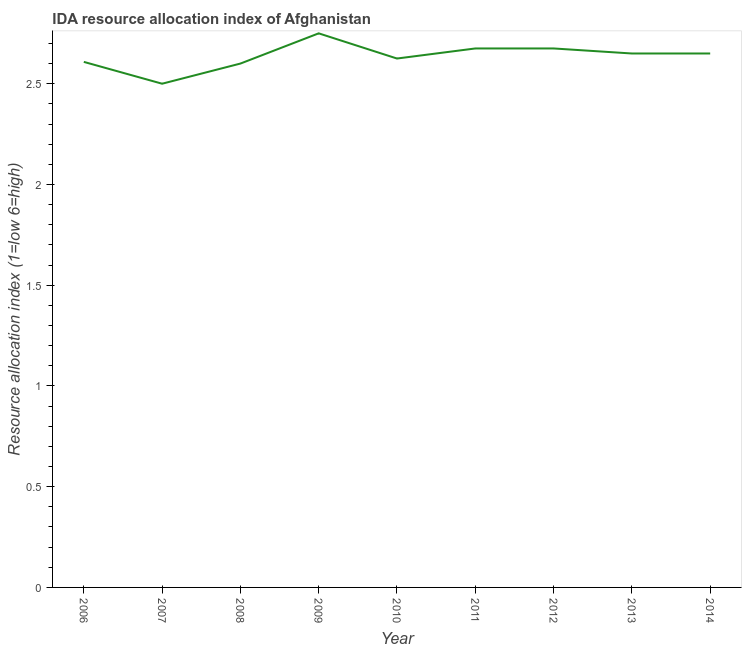Across all years, what is the maximum ida resource allocation index?
Provide a short and direct response. 2.75. Across all years, what is the minimum ida resource allocation index?
Provide a short and direct response. 2.5. In which year was the ida resource allocation index maximum?
Offer a very short reply. 2009. In which year was the ida resource allocation index minimum?
Make the answer very short. 2007. What is the sum of the ida resource allocation index?
Provide a succinct answer. 23.73. What is the difference between the ida resource allocation index in 2007 and 2009?
Offer a terse response. -0.25. What is the average ida resource allocation index per year?
Offer a very short reply. 2.64. What is the median ida resource allocation index?
Provide a short and direct response. 2.65. In how many years, is the ida resource allocation index greater than 2.4 ?
Provide a succinct answer. 9. What is the ratio of the ida resource allocation index in 2010 to that in 2014?
Offer a terse response. 0.99. Is the difference between the ida resource allocation index in 2006 and 2010 greater than the difference between any two years?
Provide a succinct answer. No. What is the difference between the highest and the second highest ida resource allocation index?
Your response must be concise. 0.08. Is the sum of the ida resource allocation index in 2008 and 2011 greater than the maximum ida resource allocation index across all years?
Make the answer very short. Yes. In how many years, is the ida resource allocation index greater than the average ida resource allocation index taken over all years?
Provide a succinct answer. 5. Does the ida resource allocation index monotonically increase over the years?
Provide a succinct answer. No. How many lines are there?
Your response must be concise. 1. What is the difference between two consecutive major ticks on the Y-axis?
Your answer should be very brief. 0.5. Are the values on the major ticks of Y-axis written in scientific E-notation?
Provide a short and direct response. No. Does the graph contain any zero values?
Your answer should be very brief. No. What is the title of the graph?
Make the answer very short. IDA resource allocation index of Afghanistan. What is the label or title of the Y-axis?
Provide a short and direct response. Resource allocation index (1=low 6=high). What is the Resource allocation index (1=low 6=high) in 2006?
Ensure brevity in your answer.  2.61. What is the Resource allocation index (1=low 6=high) in 2008?
Ensure brevity in your answer.  2.6. What is the Resource allocation index (1=low 6=high) in 2009?
Your response must be concise. 2.75. What is the Resource allocation index (1=low 6=high) of 2010?
Make the answer very short. 2.62. What is the Resource allocation index (1=low 6=high) of 2011?
Offer a terse response. 2.67. What is the Resource allocation index (1=low 6=high) in 2012?
Provide a short and direct response. 2.67. What is the Resource allocation index (1=low 6=high) in 2013?
Keep it short and to the point. 2.65. What is the Resource allocation index (1=low 6=high) of 2014?
Make the answer very short. 2.65. What is the difference between the Resource allocation index (1=low 6=high) in 2006 and 2007?
Give a very brief answer. 0.11. What is the difference between the Resource allocation index (1=low 6=high) in 2006 and 2008?
Your response must be concise. 0.01. What is the difference between the Resource allocation index (1=low 6=high) in 2006 and 2009?
Your response must be concise. -0.14. What is the difference between the Resource allocation index (1=low 6=high) in 2006 and 2010?
Offer a terse response. -0.02. What is the difference between the Resource allocation index (1=low 6=high) in 2006 and 2011?
Your response must be concise. -0.07. What is the difference between the Resource allocation index (1=low 6=high) in 2006 and 2012?
Your response must be concise. -0.07. What is the difference between the Resource allocation index (1=low 6=high) in 2006 and 2013?
Your answer should be compact. -0.04. What is the difference between the Resource allocation index (1=low 6=high) in 2006 and 2014?
Ensure brevity in your answer.  -0.04. What is the difference between the Resource allocation index (1=low 6=high) in 2007 and 2010?
Your answer should be compact. -0.12. What is the difference between the Resource allocation index (1=low 6=high) in 2007 and 2011?
Offer a terse response. -0.17. What is the difference between the Resource allocation index (1=low 6=high) in 2007 and 2012?
Give a very brief answer. -0.17. What is the difference between the Resource allocation index (1=low 6=high) in 2008 and 2009?
Ensure brevity in your answer.  -0.15. What is the difference between the Resource allocation index (1=low 6=high) in 2008 and 2010?
Ensure brevity in your answer.  -0.03. What is the difference between the Resource allocation index (1=low 6=high) in 2008 and 2011?
Your answer should be compact. -0.07. What is the difference between the Resource allocation index (1=low 6=high) in 2008 and 2012?
Provide a succinct answer. -0.07. What is the difference between the Resource allocation index (1=low 6=high) in 2008 and 2013?
Your answer should be very brief. -0.05. What is the difference between the Resource allocation index (1=low 6=high) in 2008 and 2014?
Provide a succinct answer. -0.05. What is the difference between the Resource allocation index (1=low 6=high) in 2009 and 2010?
Keep it short and to the point. 0.12. What is the difference between the Resource allocation index (1=low 6=high) in 2009 and 2011?
Make the answer very short. 0.07. What is the difference between the Resource allocation index (1=low 6=high) in 2009 and 2012?
Keep it short and to the point. 0.07. What is the difference between the Resource allocation index (1=low 6=high) in 2009 and 2013?
Ensure brevity in your answer.  0.1. What is the difference between the Resource allocation index (1=low 6=high) in 2010 and 2011?
Your answer should be very brief. -0.05. What is the difference between the Resource allocation index (1=low 6=high) in 2010 and 2013?
Give a very brief answer. -0.03. What is the difference between the Resource allocation index (1=low 6=high) in 2010 and 2014?
Make the answer very short. -0.03. What is the difference between the Resource allocation index (1=low 6=high) in 2011 and 2013?
Ensure brevity in your answer.  0.03. What is the difference between the Resource allocation index (1=low 6=high) in 2011 and 2014?
Make the answer very short. 0.03. What is the difference between the Resource allocation index (1=low 6=high) in 2012 and 2013?
Provide a succinct answer. 0.03. What is the difference between the Resource allocation index (1=low 6=high) in 2012 and 2014?
Provide a succinct answer. 0.03. What is the ratio of the Resource allocation index (1=low 6=high) in 2006 to that in 2007?
Provide a short and direct response. 1.04. What is the ratio of the Resource allocation index (1=low 6=high) in 2006 to that in 2009?
Make the answer very short. 0.95. What is the ratio of the Resource allocation index (1=low 6=high) in 2006 to that in 2012?
Give a very brief answer. 0.97. What is the ratio of the Resource allocation index (1=low 6=high) in 2006 to that in 2013?
Give a very brief answer. 0.98. What is the ratio of the Resource allocation index (1=low 6=high) in 2007 to that in 2008?
Your answer should be compact. 0.96. What is the ratio of the Resource allocation index (1=low 6=high) in 2007 to that in 2009?
Offer a very short reply. 0.91. What is the ratio of the Resource allocation index (1=low 6=high) in 2007 to that in 2010?
Ensure brevity in your answer.  0.95. What is the ratio of the Resource allocation index (1=low 6=high) in 2007 to that in 2011?
Offer a terse response. 0.94. What is the ratio of the Resource allocation index (1=low 6=high) in 2007 to that in 2012?
Ensure brevity in your answer.  0.94. What is the ratio of the Resource allocation index (1=low 6=high) in 2007 to that in 2013?
Ensure brevity in your answer.  0.94. What is the ratio of the Resource allocation index (1=low 6=high) in 2007 to that in 2014?
Keep it short and to the point. 0.94. What is the ratio of the Resource allocation index (1=low 6=high) in 2008 to that in 2009?
Keep it short and to the point. 0.94. What is the ratio of the Resource allocation index (1=low 6=high) in 2008 to that in 2011?
Your answer should be compact. 0.97. What is the ratio of the Resource allocation index (1=low 6=high) in 2008 to that in 2012?
Make the answer very short. 0.97. What is the ratio of the Resource allocation index (1=low 6=high) in 2008 to that in 2013?
Your answer should be compact. 0.98. What is the ratio of the Resource allocation index (1=low 6=high) in 2009 to that in 2010?
Offer a very short reply. 1.05. What is the ratio of the Resource allocation index (1=low 6=high) in 2009 to that in 2011?
Offer a terse response. 1.03. What is the ratio of the Resource allocation index (1=low 6=high) in 2009 to that in 2012?
Offer a terse response. 1.03. What is the ratio of the Resource allocation index (1=low 6=high) in 2009 to that in 2013?
Your answer should be compact. 1.04. What is the ratio of the Resource allocation index (1=low 6=high) in 2009 to that in 2014?
Your answer should be compact. 1.04. What is the ratio of the Resource allocation index (1=low 6=high) in 2010 to that in 2012?
Your response must be concise. 0.98. What is the ratio of the Resource allocation index (1=low 6=high) in 2010 to that in 2013?
Keep it short and to the point. 0.99. What is the ratio of the Resource allocation index (1=low 6=high) in 2011 to that in 2013?
Your answer should be very brief. 1.01. What is the ratio of the Resource allocation index (1=low 6=high) in 2011 to that in 2014?
Your answer should be very brief. 1.01. 